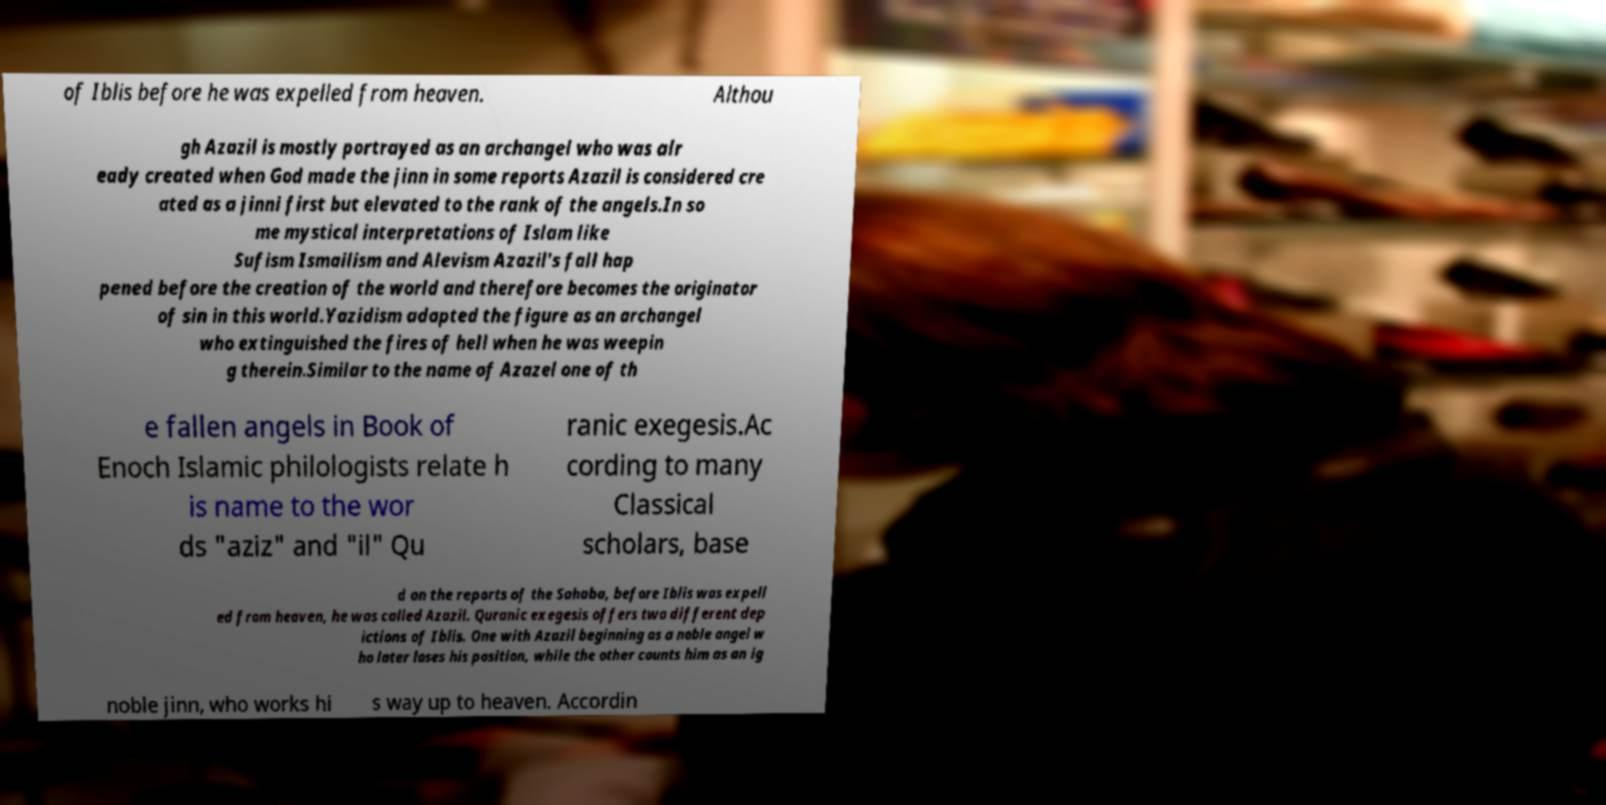Could you extract and type out the text from this image? of Iblis before he was expelled from heaven. Althou gh Azazil is mostly portrayed as an archangel who was alr eady created when God made the jinn in some reports Azazil is considered cre ated as a jinni first but elevated to the rank of the angels.In so me mystical interpretations of Islam like Sufism Ismailism and Alevism Azazil's fall hap pened before the creation of the world and therefore becomes the originator of sin in this world.Yazidism adapted the figure as an archangel who extinguished the fires of hell when he was weepin g therein.Similar to the name of Azazel one of th e fallen angels in Book of Enoch Islamic philologists relate h is name to the wor ds "aziz" and "il" Qu ranic exegesis.Ac cording to many Classical scholars, base d on the reports of the Sahaba, before Iblis was expell ed from heaven, he was called Azazil. Quranic exegesis offers two different dep ictions of Iblis. One with Azazil beginning as a noble angel w ho later loses his position, while the other counts him as an ig noble jinn, who works hi s way up to heaven. Accordin 